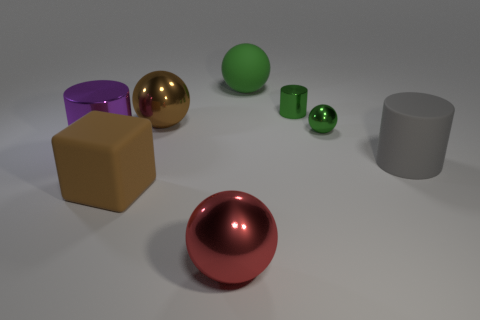Subtract 1 balls. How many balls are left? 3 Add 2 small yellow spheres. How many objects exist? 10 Subtract all blocks. How many objects are left? 7 Add 3 green objects. How many green objects are left? 6 Add 3 large gray objects. How many large gray objects exist? 4 Subtract 0 yellow spheres. How many objects are left? 8 Subtract all large matte spheres. Subtract all big metallic spheres. How many objects are left? 5 